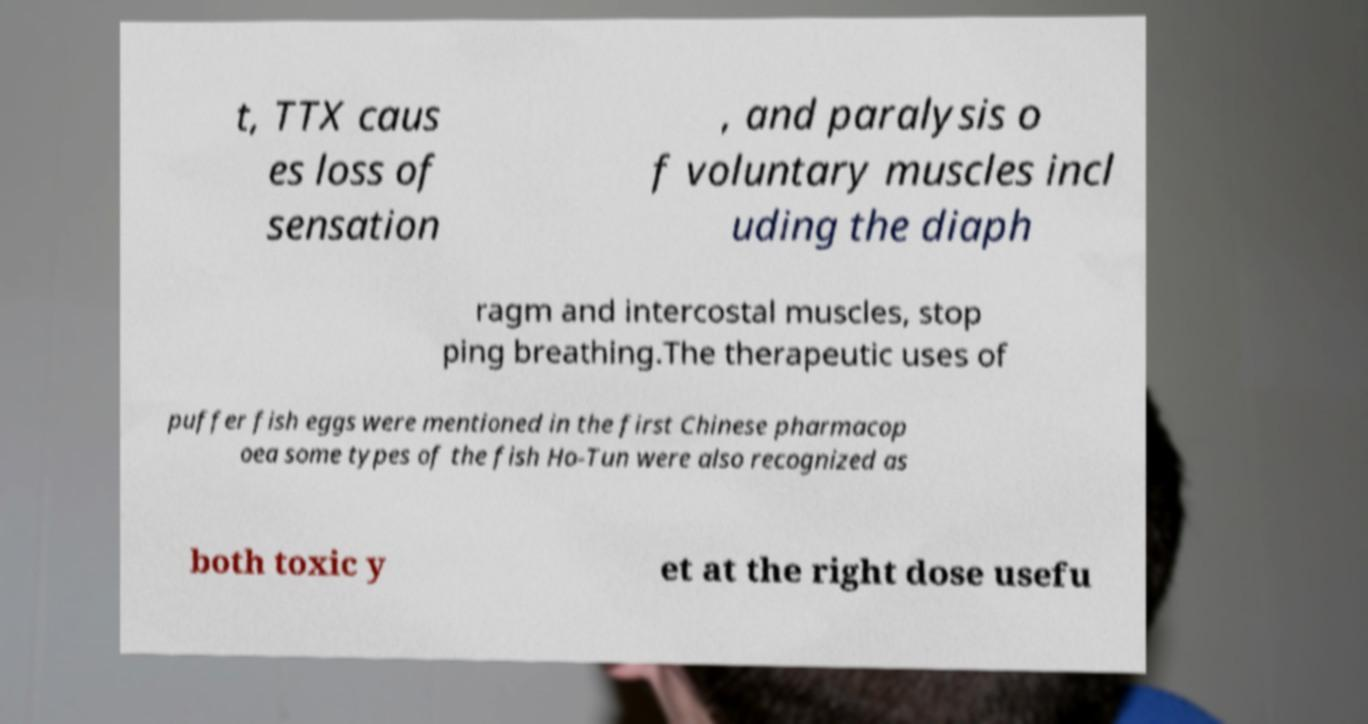Please read and relay the text visible in this image. What does it say? t, TTX caus es loss of sensation , and paralysis o f voluntary muscles incl uding the diaph ragm and intercostal muscles, stop ping breathing.The therapeutic uses of puffer fish eggs were mentioned in the first Chinese pharmacop oea some types of the fish Ho-Tun were also recognized as both toxic y et at the right dose usefu 